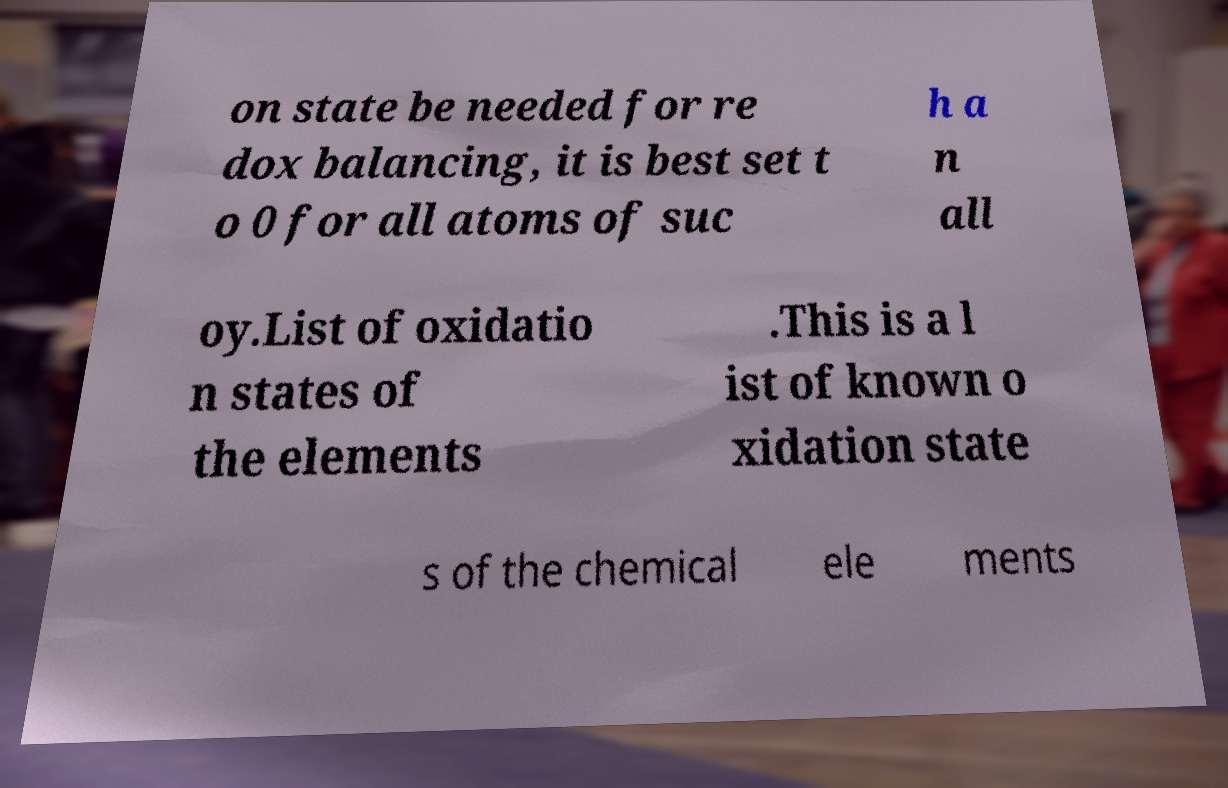I need the written content from this picture converted into text. Can you do that? on state be needed for re dox balancing, it is best set t o 0 for all atoms of suc h a n all oy.List of oxidatio n states of the elements .This is a l ist of known o xidation state s of the chemical ele ments 